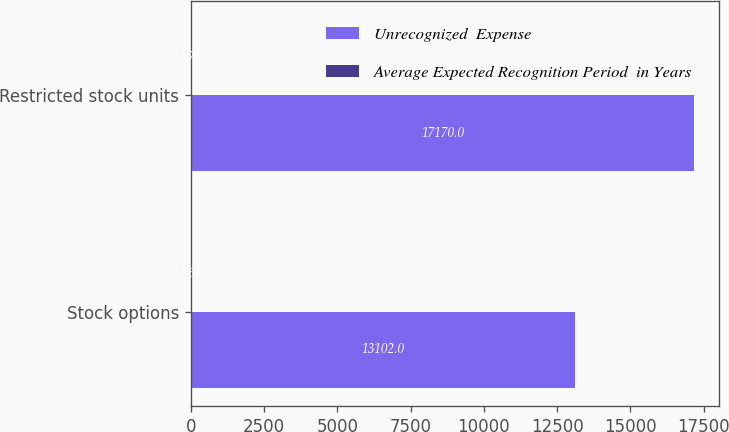Convert chart. <chart><loc_0><loc_0><loc_500><loc_500><stacked_bar_chart><ecel><fcel>Stock options<fcel>Restricted stock units<nl><fcel>Unrecognized  Expense<fcel>13102<fcel>17170<nl><fcel>Average Expected Recognition Period  in Years<fcel>2.67<fcel>2.74<nl></chart> 